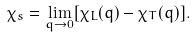<formula> <loc_0><loc_0><loc_500><loc_500>\chi _ { s } = \lim _ { q \to 0 } [ \chi _ { L } ( q ) - \chi _ { T } ( q ) ] .</formula> 